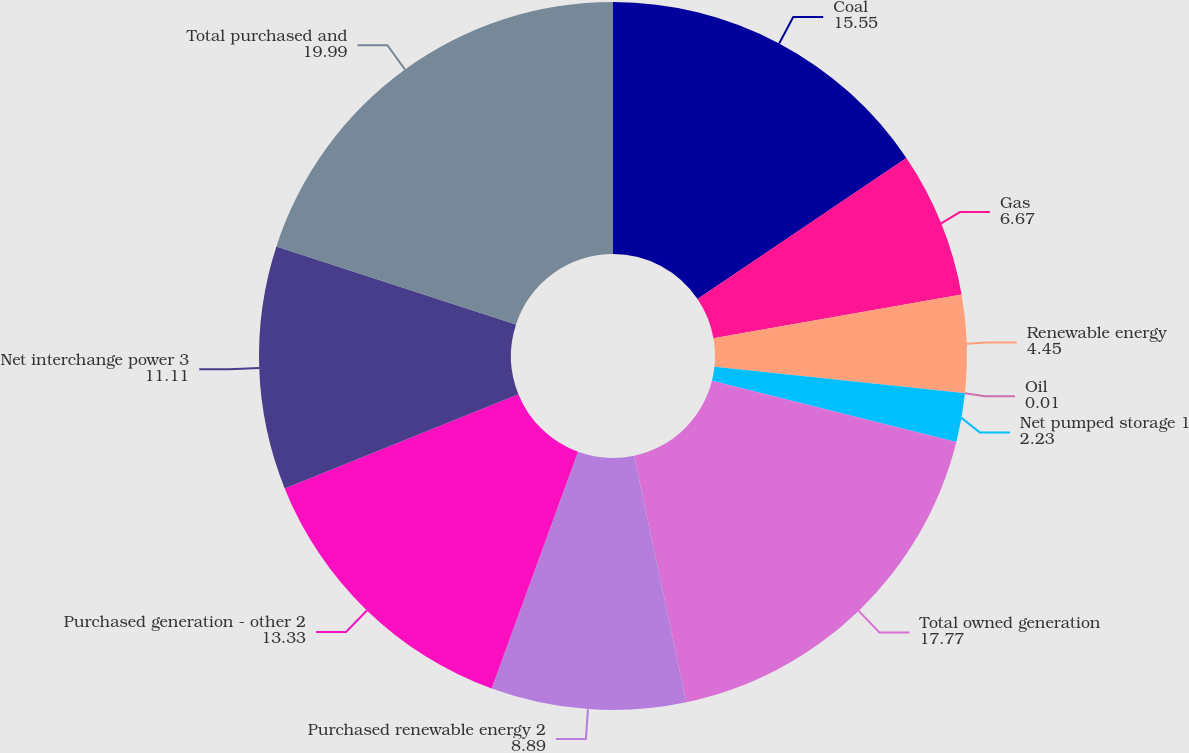Convert chart. <chart><loc_0><loc_0><loc_500><loc_500><pie_chart><fcel>Coal<fcel>Gas<fcel>Renewable energy<fcel>Oil<fcel>Net pumped storage 1<fcel>Total owned generation<fcel>Purchased renewable energy 2<fcel>Purchased generation - other 2<fcel>Net interchange power 3<fcel>Total purchased and<nl><fcel>15.55%<fcel>6.67%<fcel>4.45%<fcel>0.01%<fcel>2.23%<fcel>17.77%<fcel>8.89%<fcel>13.33%<fcel>11.11%<fcel>19.99%<nl></chart> 